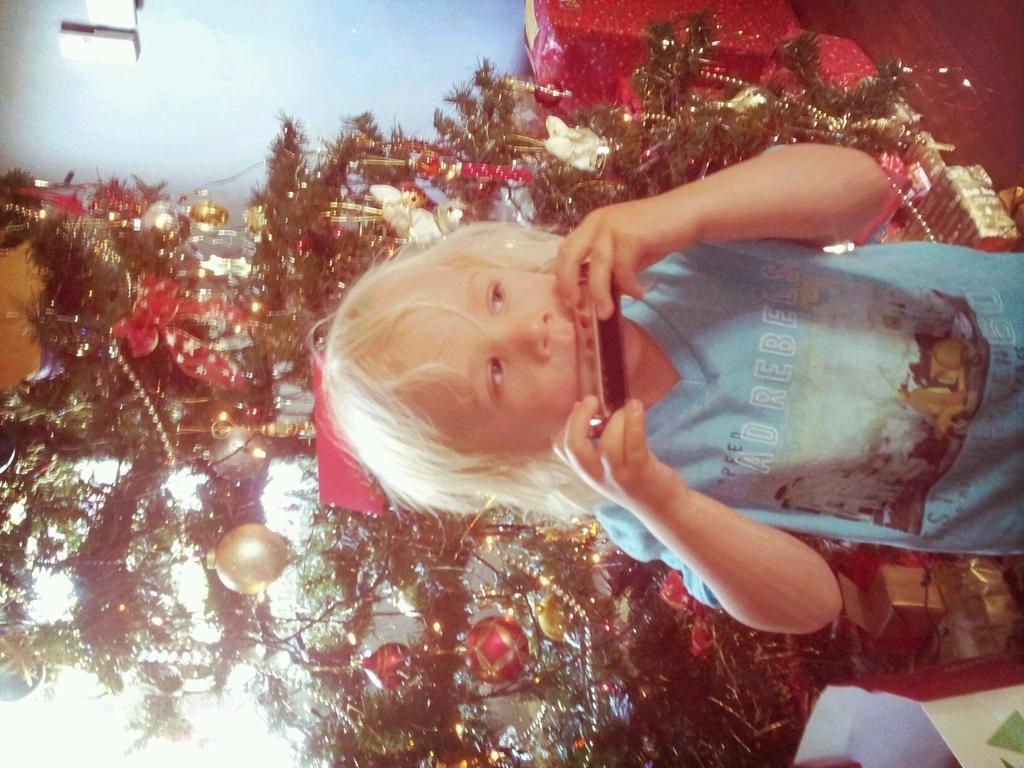How would you summarize this image in a sentence or two? In this image there is a boy standing towards the right of the image, he is holding an object, there is a Christmas tree behind the boy, there is an object towards the bottom of the image, there is floor towards the top of the image, there is an object towards the top of the image, there is a wall towards the top of the image, there is an object on the wall. 